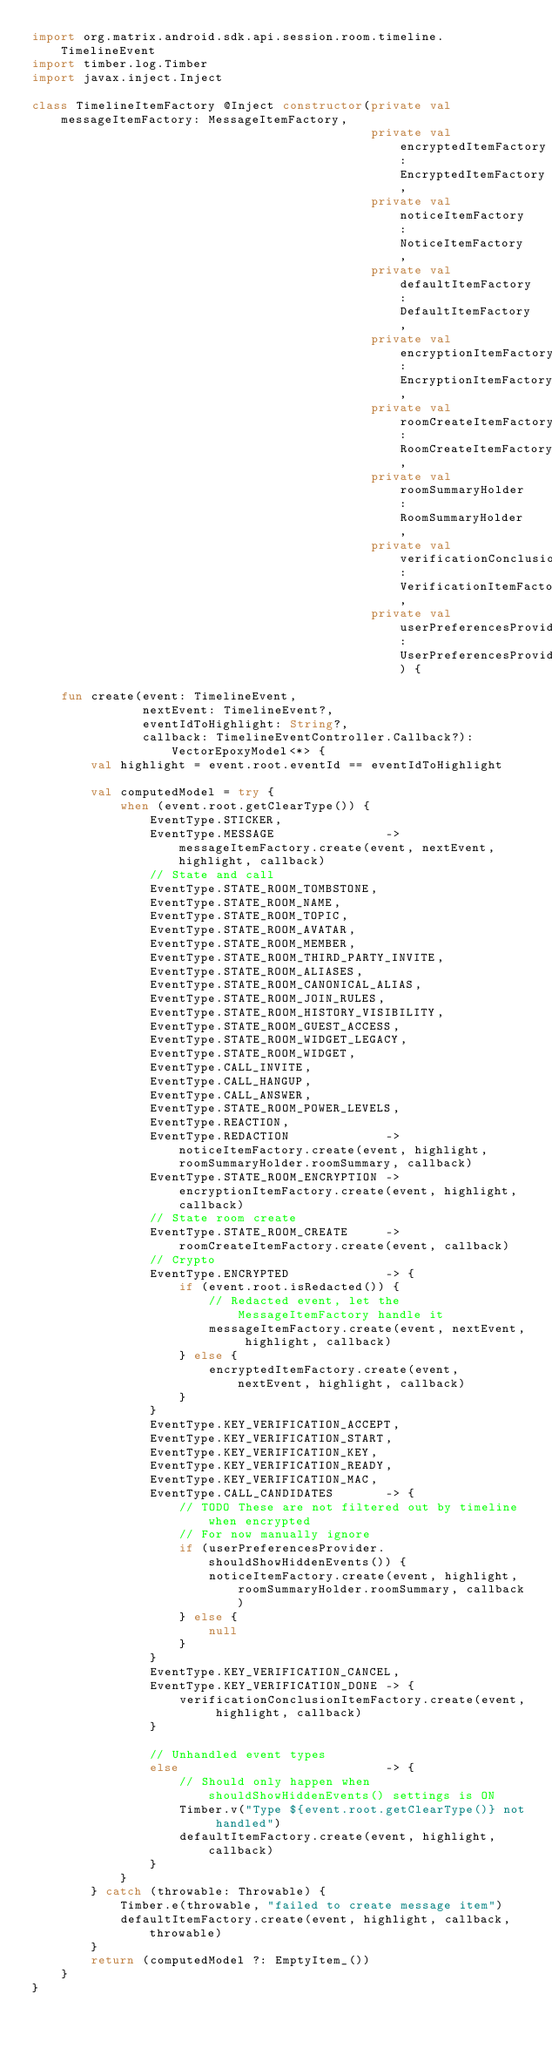Convert code to text. <code><loc_0><loc_0><loc_500><loc_500><_Kotlin_>import org.matrix.android.sdk.api.session.room.timeline.TimelineEvent
import timber.log.Timber
import javax.inject.Inject

class TimelineItemFactory @Inject constructor(private val messageItemFactory: MessageItemFactory,
                                              private val encryptedItemFactory: EncryptedItemFactory,
                                              private val noticeItemFactory: NoticeItemFactory,
                                              private val defaultItemFactory: DefaultItemFactory,
                                              private val encryptionItemFactory: EncryptionItemFactory,
                                              private val roomCreateItemFactory: RoomCreateItemFactory,
                                              private val roomSummaryHolder: RoomSummaryHolder,
                                              private val verificationConclusionItemFactory: VerificationItemFactory,
                                              private val userPreferencesProvider: UserPreferencesProvider) {

    fun create(event: TimelineEvent,
               nextEvent: TimelineEvent?,
               eventIdToHighlight: String?,
               callback: TimelineEventController.Callback?): VectorEpoxyModel<*> {
        val highlight = event.root.eventId == eventIdToHighlight

        val computedModel = try {
            when (event.root.getClearType()) {
                EventType.STICKER,
                EventType.MESSAGE               -> messageItemFactory.create(event, nextEvent, highlight, callback)
                // State and call
                EventType.STATE_ROOM_TOMBSTONE,
                EventType.STATE_ROOM_NAME,
                EventType.STATE_ROOM_TOPIC,
                EventType.STATE_ROOM_AVATAR,
                EventType.STATE_ROOM_MEMBER,
                EventType.STATE_ROOM_THIRD_PARTY_INVITE,
                EventType.STATE_ROOM_ALIASES,
                EventType.STATE_ROOM_CANONICAL_ALIAS,
                EventType.STATE_ROOM_JOIN_RULES,
                EventType.STATE_ROOM_HISTORY_VISIBILITY,
                EventType.STATE_ROOM_GUEST_ACCESS,
                EventType.STATE_ROOM_WIDGET_LEGACY,
                EventType.STATE_ROOM_WIDGET,
                EventType.CALL_INVITE,
                EventType.CALL_HANGUP,
                EventType.CALL_ANSWER,
                EventType.STATE_ROOM_POWER_LEVELS,
                EventType.REACTION,
                EventType.REDACTION             -> noticeItemFactory.create(event, highlight, roomSummaryHolder.roomSummary, callback)
                EventType.STATE_ROOM_ENCRYPTION -> encryptionItemFactory.create(event, highlight, callback)
                // State room create
                EventType.STATE_ROOM_CREATE     -> roomCreateItemFactory.create(event, callback)
                // Crypto
                EventType.ENCRYPTED             -> {
                    if (event.root.isRedacted()) {
                        // Redacted event, let the MessageItemFactory handle it
                        messageItemFactory.create(event, nextEvent, highlight, callback)
                    } else {
                        encryptedItemFactory.create(event, nextEvent, highlight, callback)
                    }
                }
                EventType.KEY_VERIFICATION_ACCEPT,
                EventType.KEY_VERIFICATION_START,
                EventType.KEY_VERIFICATION_KEY,
                EventType.KEY_VERIFICATION_READY,
                EventType.KEY_VERIFICATION_MAC,
                EventType.CALL_CANDIDATES       -> {
                    // TODO These are not filtered out by timeline when encrypted
                    // For now manually ignore
                    if (userPreferencesProvider.shouldShowHiddenEvents()) {
                        noticeItemFactory.create(event, highlight, roomSummaryHolder.roomSummary, callback)
                    } else {
                        null
                    }
                }
                EventType.KEY_VERIFICATION_CANCEL,
                EventType.KEY_VERIFICATION_DONE -> {
                    verificationConclusionItemFactory.create(event, highlight, callback)
                }

                // Unhandled event types
                else                            -> {
                    // Should only happen when shouldShowHiddenEvents() settings is ON
                    Timber.v("Type ${event.root.getClearType()} not handled")
                    defaultItemFactory.create(event, highlight, callback)
                }
            }
        } catch (throwable: Throwable) {
            Timber.e(throwable, "failed to create message item")
            defaultItemFactory.create(event, highlight, callback, throwable)
        }
        return (computedModel ?: EmptyItem_())
    }
}
</code> 